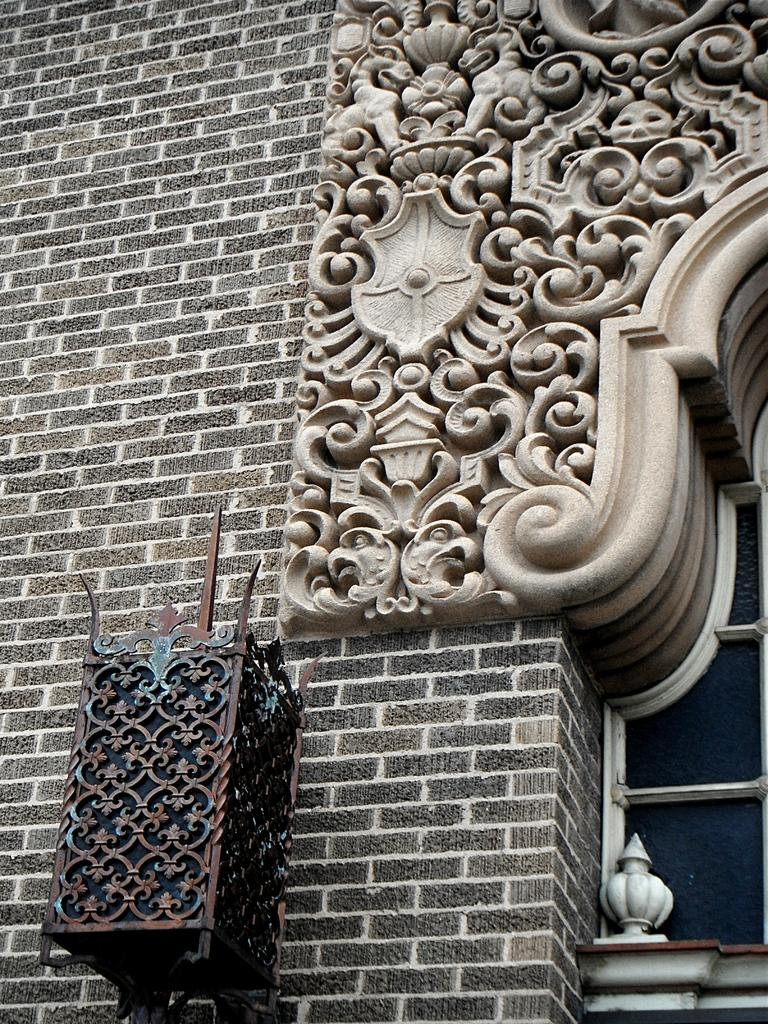What type of design can be seen on the brick wall in the image? There is a beautifully crafted design arch on the brick wall. Can you describe the design element hanging on the wall in the front? There is a metal design light box hanging on the wall in the front. What type of zephyr can be seen blowing through the design arch in the image? There is no zephyr present in the image; it is a brick wall with a design arch and a metal light box. Is there a stage visible in the image? There is no stage present in the image; it features a brick wall with a design arch and a metal light box hanging on the wall. 